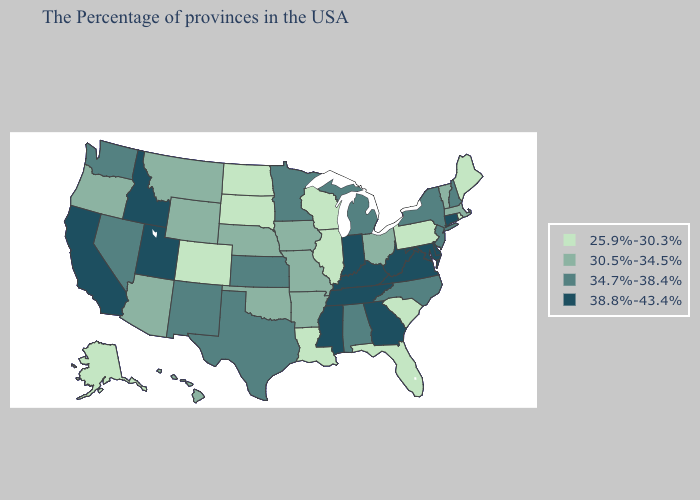Which states have the lowest value in the MidWest?
Keep it brief. Wisconsin, Illinois, South Dakota, North Dakota. Does Nebraska have the lowest value in the MidWest?
Keep it brief. No. Name the states that have a value in the range 38.8%-43.4%?
Answer briefly. Connecticut, Delaware, Maryland, Virginia, West Virginia, Georgia, Kentucky, Indiana, Tennessee, Mississippi, Utah, Idaho, California. What is the value of South Carolina?
Concise answer only. 25.9%-30.3%. What is the highest value in the MidWest ?
Keep it brief. 38.8%-43.4%. What is the highest value in states that border North Carolina?
Quick response, please. 38.8%-43.4%. Name the states that have a value in the range 30.5%-34.5%?
Keep it brief. Massachusetts, Vermont, Ohio, Missouri, Arkansas, Iowa, Nebraska, Oklahoma, Wyoming, Montana, Arizona, Oregon, Hawaii. What is the value of Florida?
Give a very brief answer. 25.9%-30.3%. Name the states that have a value in the range 30.5%-34.5%?
Keep it brief. Massachusetts, Vermont, Ohio, Missouri, Arkansas, Iowa, Nebraska, Oklahoma, Wyoming, Montana, Arizona, Oregon, Hawaii. What is the value of Indiana?
Quick response, please. 38.8%-43.4%. What is the lowest value in the MidWest?
Keep it brief. 25.9%-30.3%. Does the first symbol in the legend represent the smallest category?
Keep it brief. Yes. What is the lowest value in the MidWest?
Short answer required. 25.9%-30.3%. Does Louisiana have a lower value than Tennessee?
Concise answer only. Yes. What is the value of Pennsylvania?
Quick response, please. 25.9%-30.3%. 